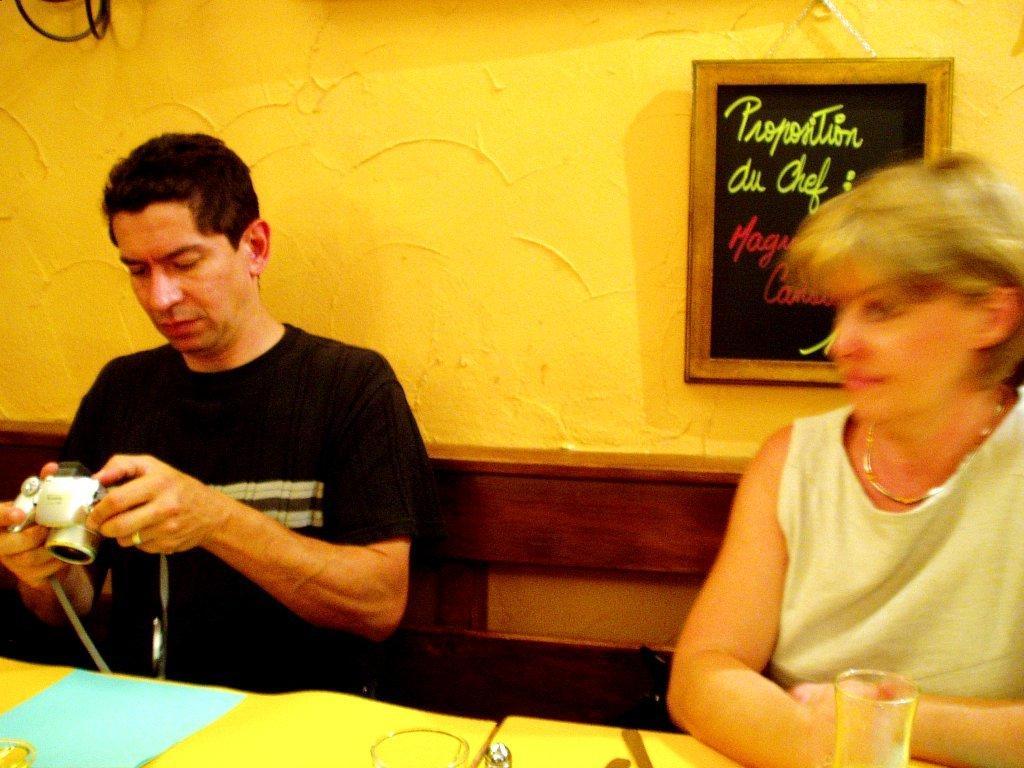Can you describe this image briefly? Here we can see a man and a woman sitting on the chairs. He is holding a camera with his hands. This is table. On the table there are glasses. On the background there is a wall and this is frame. 